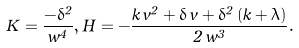Convert formula to latex. <formula><loc_0><loc_0><loc_500><loc_500>K = \frac { - \delta ^ { 2 } } { w ^ { 4 } } , H = - \frac { k \, v ^ { 2 } + \delta \, v + \delta ^ { 2 } \left ( k + \lambda \right ) } { 2 \, w ^ { 3 } } .</formula> 